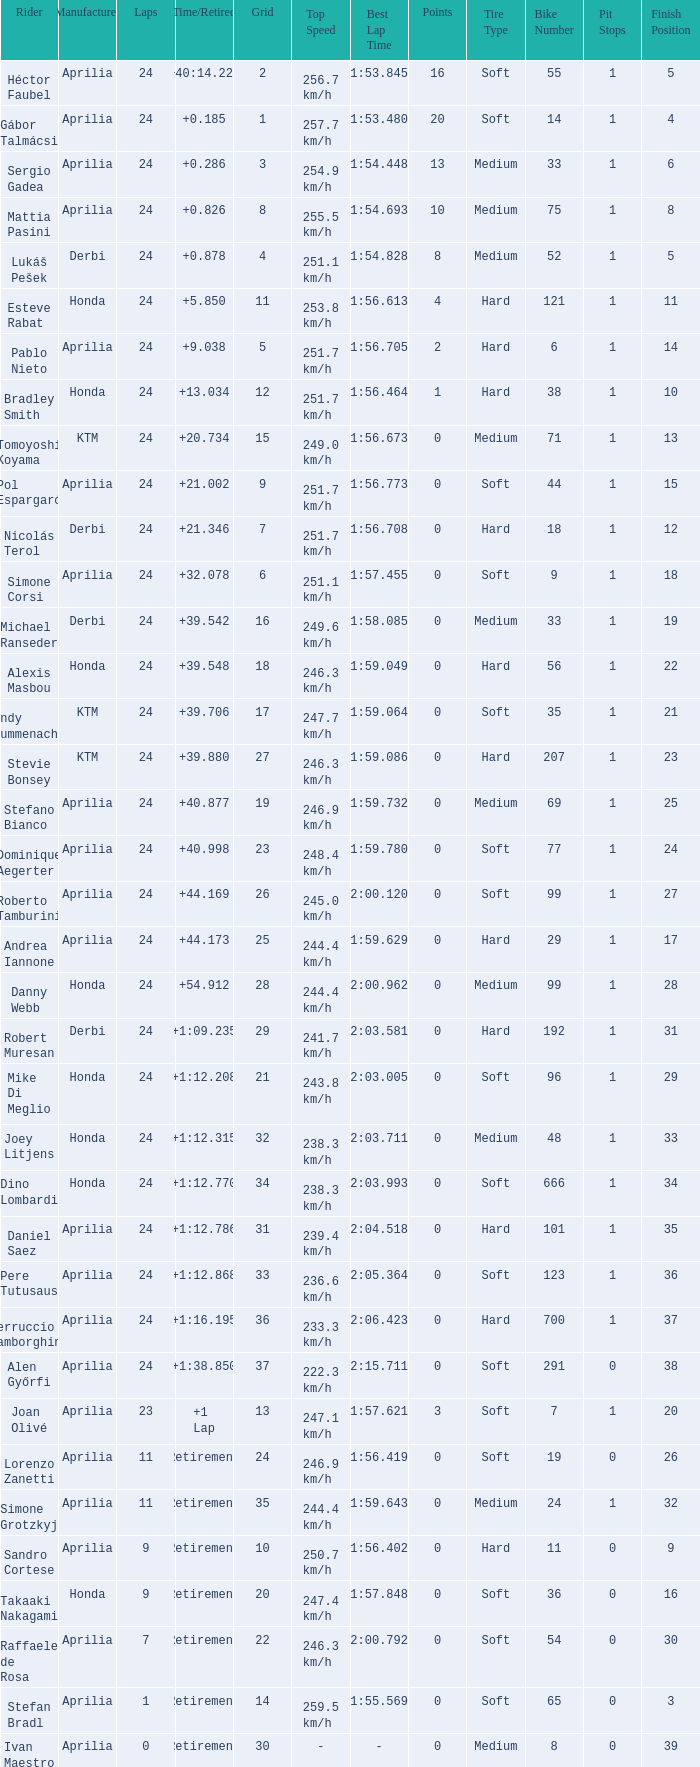Help me parse the entirety of this table. {'header': ['Rider', 'Manufacturer', 'Laps', 'Time/Retired', 'Grid', 'Top Speed', 'Best Lap Time', 'Points', 'Tire Type', 'Bike Number', 'Pit Stops', 'Finish Position'], 'rows': [['Héctor Faubel', 'Aprilia', '24', '+40:14.228', '2', '256.7 km/h', '1:53.845', '16', 'Soft', '55', '1', '5'], ['Gábor Talmácsi', 'Aprilia', '24', '+0.185', '1', '257.7 km/h', '1:53.480', '20', 'Soft', '14', '1', '4'], ['Sergio Gadea', 'Aprilia', '24', '+0.286', '3', '254.9 km/h', '1:54.448', '13', 'Medium', '33', '1', '6'], ['Mattia Pasini', 'Aprilia', '24', '+0.826', '8', '255.5 km/h', '1:54.693', '10', 'Medium', '75', '1', '8'], ['Lukáš Pešek', 'Derbi', '24', '+0.878', '4', '251.1 km/h', '1:54.828', '8', 'Medium', '52', '1', '5'], ['Esteve Rabat', 'Honda', '24', '+5.850', '11', '253.8 km/h', '1:56.613', '4', 'Hard', '121', '1', '11'], ['Pablo Nieto', 'Aprilia', '24', '+9.038', '5', '251.7 km/h', '1:56.705', '2', 'Hard', '6', '1', '14'], ['Bradley Smith', 'Honda', '24', '+13.034', '12', '251.7 km/h', '1:56.464', '1', 'Hard', '38', '1', '10'], ['Tomoyoshi Koyama', 'KTM', '24', '+20.734', '15', '249.0 km/h', '1:56.673', '0', 'Medium', '71', '1', '13'], ['Pol Espargaró', 'Aprilia', '24', '+21.002', '9', '251.7 km/h', '1:56.773', '0', 'Soft', '44', '1', '15'], ['Nicolás Terol', 'Derbi', '24', '+21.346', '7', '251.7 km/h', '1:56.708', '0', 'Hard', '18', '1', '12'], ['Simone Corsi', 'Aprilia', '24', '+32.078', '6', '251.1 km/h', '1:57.455', '0', 'Soft', '9', '1', '18'], ['Michael Ranseder', 'Derbi', '24', '+39.542', '16', '249.6 km/h', '1:58.085', '0', 'Medium', '33', '1', '19'], ['Alexis Masbou', 'Honda', '24', '+39.548', '18', '246.3 km/h', '1:59.049', '0', 'Hard', '56', '1', '22'], ['Randy Krummenacher', 'KTM', '24', '+39.706', '17', '247.7 km/h', '1:59.064', '0', 'Soft', '35', '1', '21'], ['Stevie Bonsey', 'KTM', '24', '+39.880', '27', '246.3 km/h', '1:59.086', '0', 'Hard', '207', '1', '23'], ['Stefano Bianco', 'Aprilia', '24', '+40.877', '19', '246.9 km/h', '1:59.732', '0', 'Medium', '69', '1', '25'], ['Dominique Aegerter', 'Aprilia', '24', '+40.998', '23', '248.4 km/h', '1:59.780', '0', 'Soft', '77', '1', '24'], ['Roberto Tamburini', 'Aprilia', '24', '+44.169', '26', '245.0 km/h', '2:00.120', '0', 'Soft', '99', '1', '27'], ['Andrea Iannone', 'Aprilia', '24', '+44.173', '25', '244.4 km/h', '1:59.629', '0', 'Hard', '29', '1', '17'], ['Danny Webb', 'Honda', '24', '+54.912', '28', '244.4 km/h', '2:00.962', '0', 'Medium', '99', '1', '28'], ['Robert Muresan', 'Derbi', '24', '+1:09.235', '29', '241.7 km/h', '2:03.581', '0', 'Hard', '192', '1', '31'], ['Mike Di Meglio', 'Honda', '24', '+1:12.208', '21', '243.8 km/h', '2:03.005', '0', 'Soft', '96', '1', '29'], ['Joey Litjens', 'Honda', '24', '+1:12.315', '32', '238.3 km/h', '2:03.711', '0', 'Medium', '48', '1', '33'], ['Dino Lombardi', 'Honda', '24', '+1:12.770', '34', '238.3 km/h', '2:03.993', '0', 'Soft', '666', '1', '34'], ['Daniel Saez', 'Aprilia', '24', '+1:12.786', '31', '239.4 km/h', '2:04.518', '0', 'Hard', '101', '1', '35'], ['Pere Tutusaus', 'Aprilia', '24', '+1:12.868', '33', '236.6 km/h', '2:05.364', '0', 'Soft', '123', '1', '36'], ['Ferruccio Lamborghini', 'Aprilia', '24', '+1:16.195', '36', '233.3 km/h', '2:06.423', '0', 'Hard', '700', '1', '37'], ['Alen Győrfi', 'Aprilia', '24', '+1:38.850', '37', '222.3 km/h', '2:15.711', '0', 'Soft', '291', '0', '38'], ['Joan Olivé', 'Aprilia', '23', '+1 Lap', '13', '247.1 km/h', '1:57.621', '3', 'Soft', '7', '1', '20'], ['Lorenzo Zanetti', 'Aprilia', '11', 'Retirement', '24', '246.9 km/h', '1:56.419', '0', 'Soft', '19', '0', '26'], ['Simone Grotzkyj', 'Aprilia', '11', 'Retirement', '35', '244.4 km/h', '1:59.643', '0', 'Medium', '24', '1', '32'], ['Sandro Cortese', 'Aprilia', '9', 'Retirement', '10', '250.7 km/h', '1:56.402', '0', 'Hard', '11', '0', '9'], ['Takaaki Nakagami', 'Honda', '9', 'Retirement', '20', '247.4 km/h', '1:57.848', '0', 'Soft', '36', '0', '16'], ['Raffaele de Rosa', 'Aprilia', '7', 'Retirement', '22', '246.3 km/h', '2:00.792', '0', 'Soft', '54', '0', '30'], ['Stefan Bradl', 'Aprilia', '1', 'Retirement', '14', '259.5 km/h', '1:55.569', '0', 'Soft', '65', '0', '3'], ['Ivan Maestro', 'Aprilia', '0', 'Retirement', '30', '-', '-', '0', 'Medium', '8', '0', '39']]} How many grids have more than 24 laps with a time/retired of +1:12.208? None. 